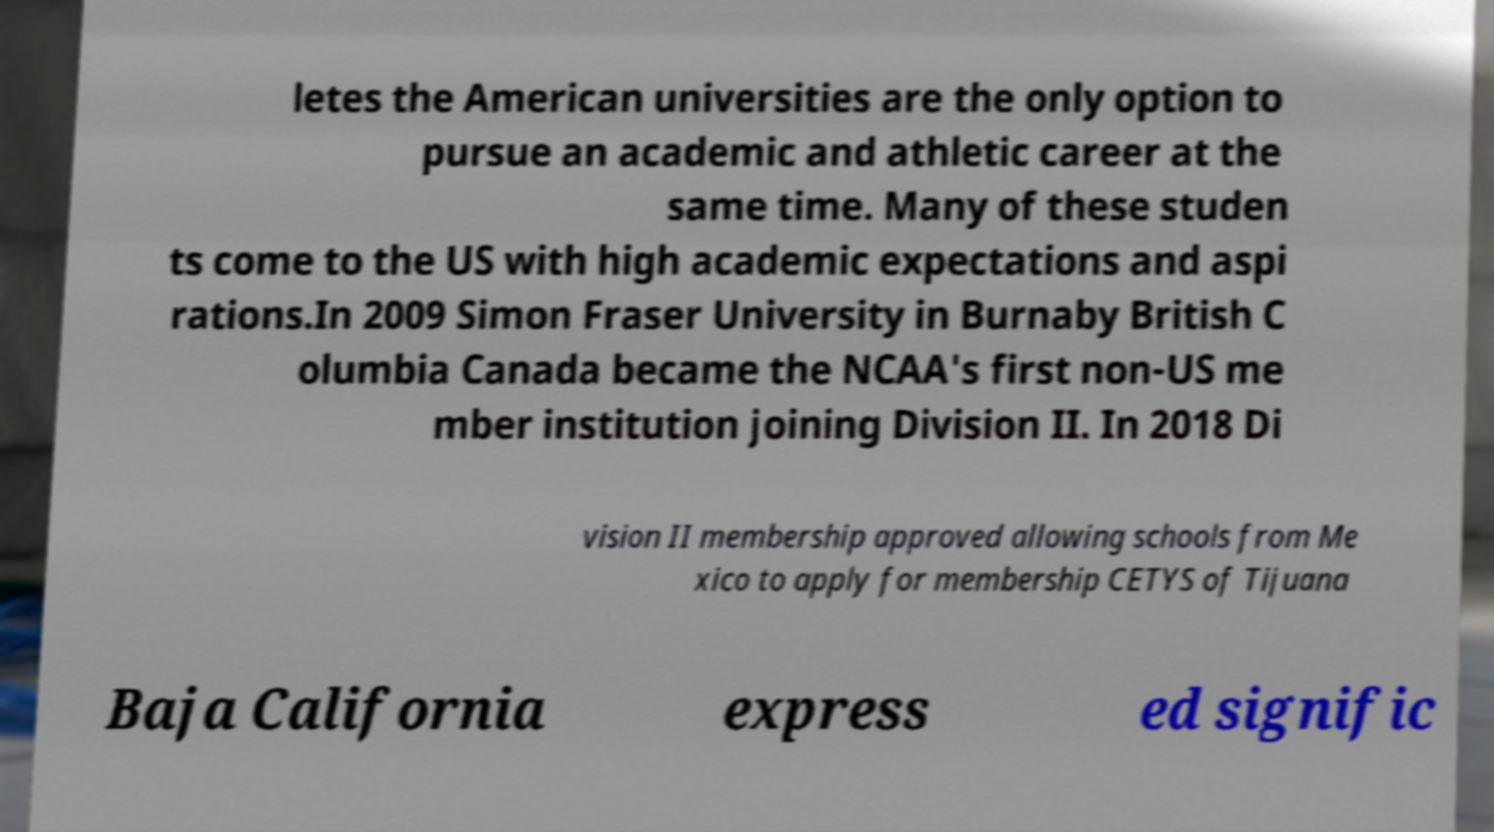For documentation purposes, I need the text within this image transcribed. Could you provide that? letes the American universities are the only option to pursue an academic and athletic career at the same time. Many of these studen ts come to the US with high academic expectations and aspi rations.In 2009 Simon Fraser University in Burnaby British C olumbia Canada became the NCAA's first non-US me mber institution joining Division II. In 2018 Di vision II membership approved allowing schools from Me xico to apply for membership CETYS of Tijuana Baja California express ed signific 